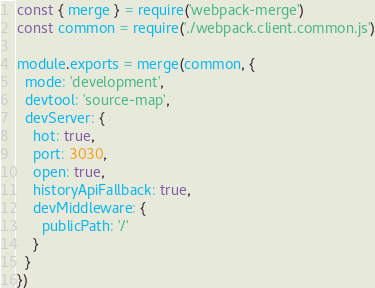<code> <loc_0><loc_0><loc_500><loc_500><_JavaScript_>const { merge } = require('webpack-merge')
const common = require('./webpack.client.common.js')

module.exports = merge(common, {
  mode: 'development',
  devtool: 'source-map',
  devServer: {
    hot: true,
    port: 3030,
    open: true,
    historyApiFallback: true,
    devMiddleware: {
      publicPath: '/'
    }
  }
})
</code> 